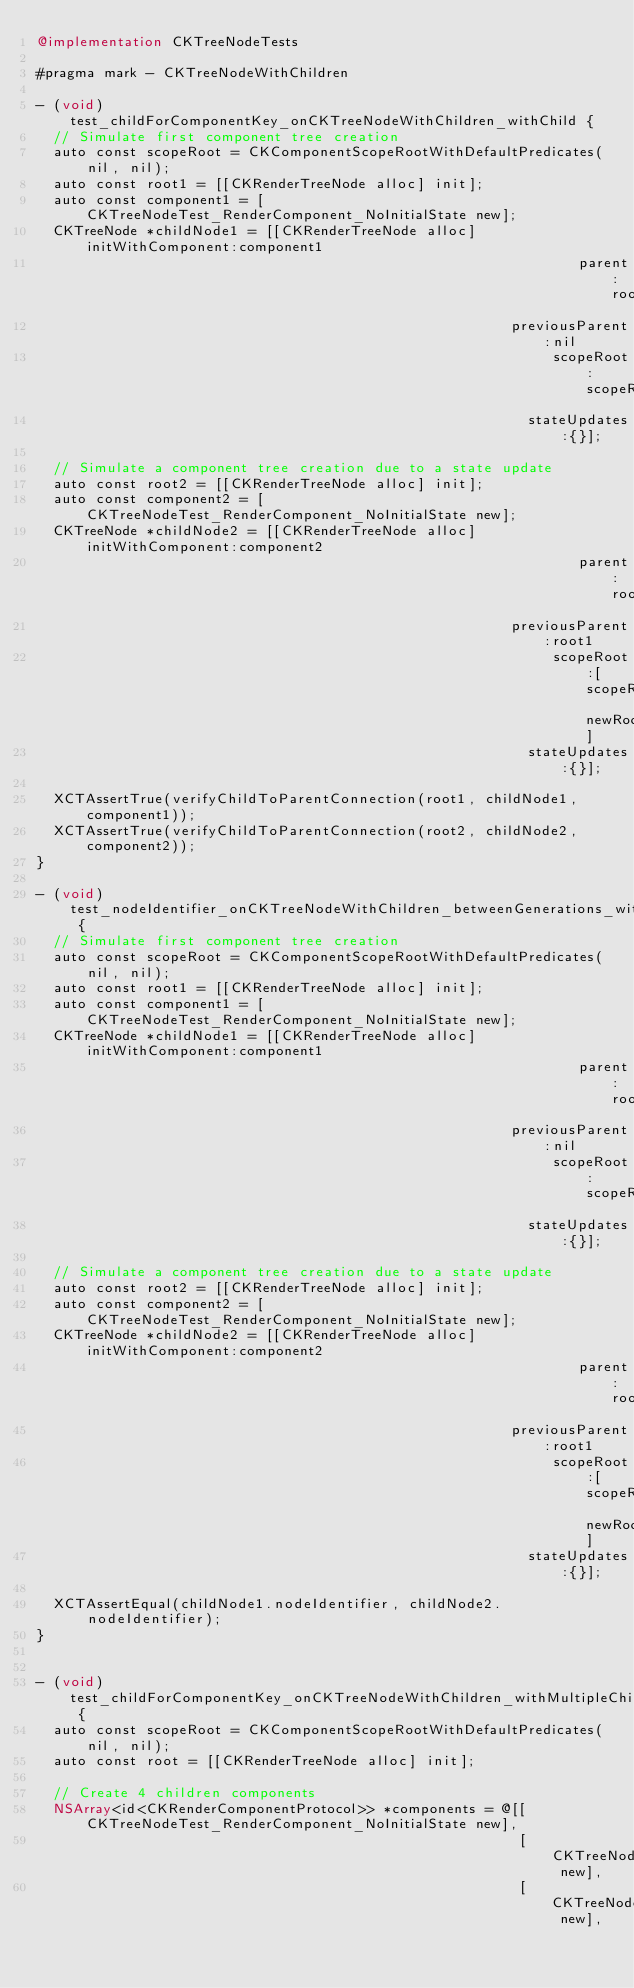Convert code to text. <code><loc_0><loc_0><loc_500><loc_500><_ObjectiveC_>@implementation CKTreeNodeTests

#pragma mark - CKTreeNodeWithChildren

- (void)test_childForComponentKey_onCKTreeNodeWithChildren_withChild {
  // Simulate first component tree creation
  auto const scopeRoot = CKComponentScopeRootWithDefaultPredicates(nil, nil);
  auto const root1 = [[CKRenderTreeNode alloc] init];
  auto const component1 = [CKTreeNodeTest_RenderComponent_NoInitialState new];
  CKTreeNode *childNode1 = [[CKRenderTreeNode alloc] initWithComponent:component1
                                                                parent:root1
                                                        previousParent:nil
                                                             scopeRoot:scopeRoot
                                                          stateUpdates:{}];

  // Simulate a component tree creation due to a state update
  auto const root2 = [[CKRenderTreeNode alloc] init];
  auto const component2 = [CKTreeNodeTest_RenderComponent_NoInitialState new];
  CKTreeNode *childNode2 = [[CKRenderTreeNode alloc] initWithComponent:component2
                                                                parent:root2
                                                        previousParent:root1
                                                             scopeRoot:[scopeRoot newRoot]
                                                          stateUpdates:{}];

  XCTAssertTrue(verifyChildToParentConnection(root1, childNode1, component1));
  XCTAssertTrue(verifyChildToParentConnection(root2, childNode2, component2));
}

- (void)test_nodeIdentifier_onCKTreeNodeWithChildren_betweenGenerations_withChild {
  // Simulate first component tree creation
  auto const scopeRoot = CKComponentScopeRootWithDefaultPredicates(nil, nil);
  auto const root1 = [[CKRenderTreeNode alloc] init];
  auto const component1 = [CKTreeNodeTest_RenderComponent_NoInitialState new];
  CKTreeNode *childNode1 = [[CKRenderTreeNode alloc] initWithComponent:component1
                                                                parent:root1
                                                        previousParent:nil
                                                             scopeRoot:scopeRoot
                                                          stateUpdates:{}];

  // Simulate a component tree creation due to a state update
  auto const root2 = [[CKRenderTreeNode alloc] init];
  auto const component2 = [CKTreeNodeTest_RenderComponent_NoInitialState new];
  CKTreeNode *childNode2 = [[CKRenderTreeNode alloc] initWithComponent:component2
                                                                parent:root2
                                                        previousParent:root1
                                                             scopeRoot:[scopeRoot newRoot]
                                                          stateUpdates:{}];

  XCTAssertEqual(childNode1.nodeIdentifier, childNode2.nodeIdentifier);
}


- (void)test_childForComponentKey_onCKTreeNodeWithChildren_withMultipleChildren {
  auto const scopeRoot = CKComponentScopeRootWithDefaultPredicates(nil, nil);
  auto const root = [[CKRenderTreeNode alloc] init];

  // Create 4 children components
  NSArray<id<CKRenderComponentProtocol>> *components = @[[CKTreeNodeTest_RenderComponent_NoInitialState new],
                                                         [CKTreeNodeTest_RenderComponent_NoInitialState new],
                                                         [CKTreeNodeTest_RenderComponent_WithState new],</code> 